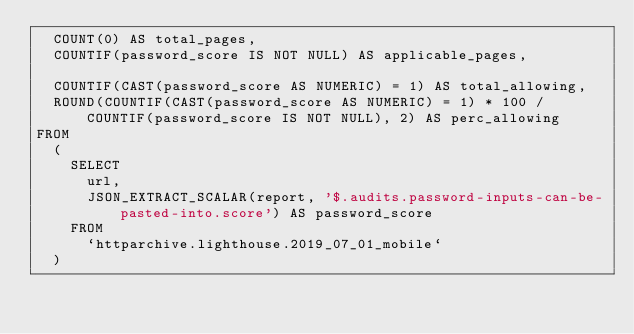<code> <loc_0><loc_0><loc_500><loc_500><_SQL_>  COUNT(0) AS total_pages,
  COUNTIF(password_score IS NOT NULL) AS applicable_pages,

  COUNTIF(CAST(password_score AS NUMERIC) = 1) AS total_allowing,
  ROUND(COUNTIF(CAST(password_score AS NUMERIC) = 1) * 100 / COUNTIF(password_score IS NOT NULL), 2) AS perc_allowing
FROM
  (
    SELECT
      url,
      JSON_EXTRACT_SCALAR(report, '$.audits.password-inputs-can-be-pasted-into.score') AS password_score
    FROM
      `httparchive.lighthouse.2019_07_01_mobile`
  )
</code> 